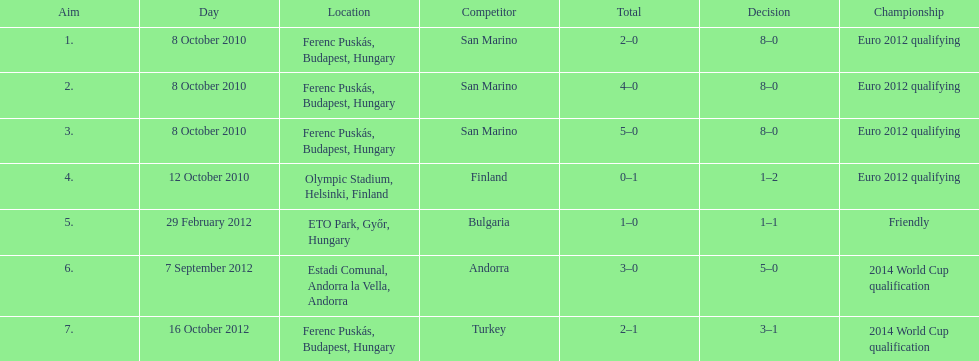How many games did he score but his team lost? 1. 